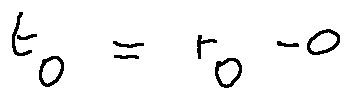Convert formula to latex. <formula><loc_0><loc_0><loc_500><loc_500>t _ { 0 } = r _ { 0 } - 0</formula> 